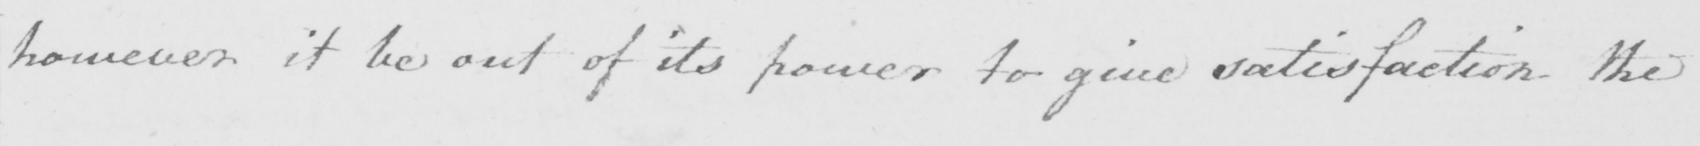What text is written in this handwritten line? however it be out of its power to give satisfaction the 